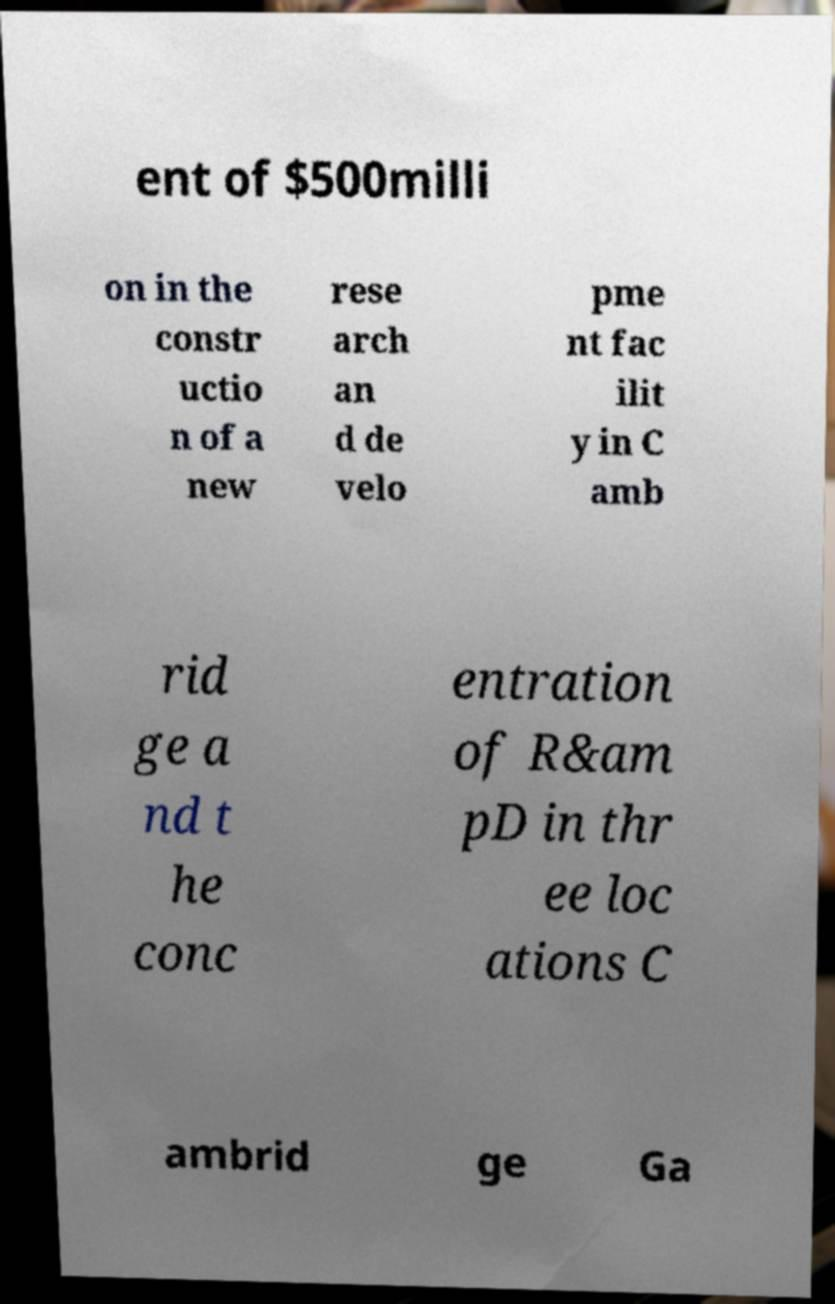Please identify and transcribe the text found in this image. ent of $500milli on in the constr uctio n of a new rese arch an d de velo pme nt fac ilit y in C amb rid ge a nd t he conc entration of R&am pD in thr ee loc ations C ambrid ge Ga 